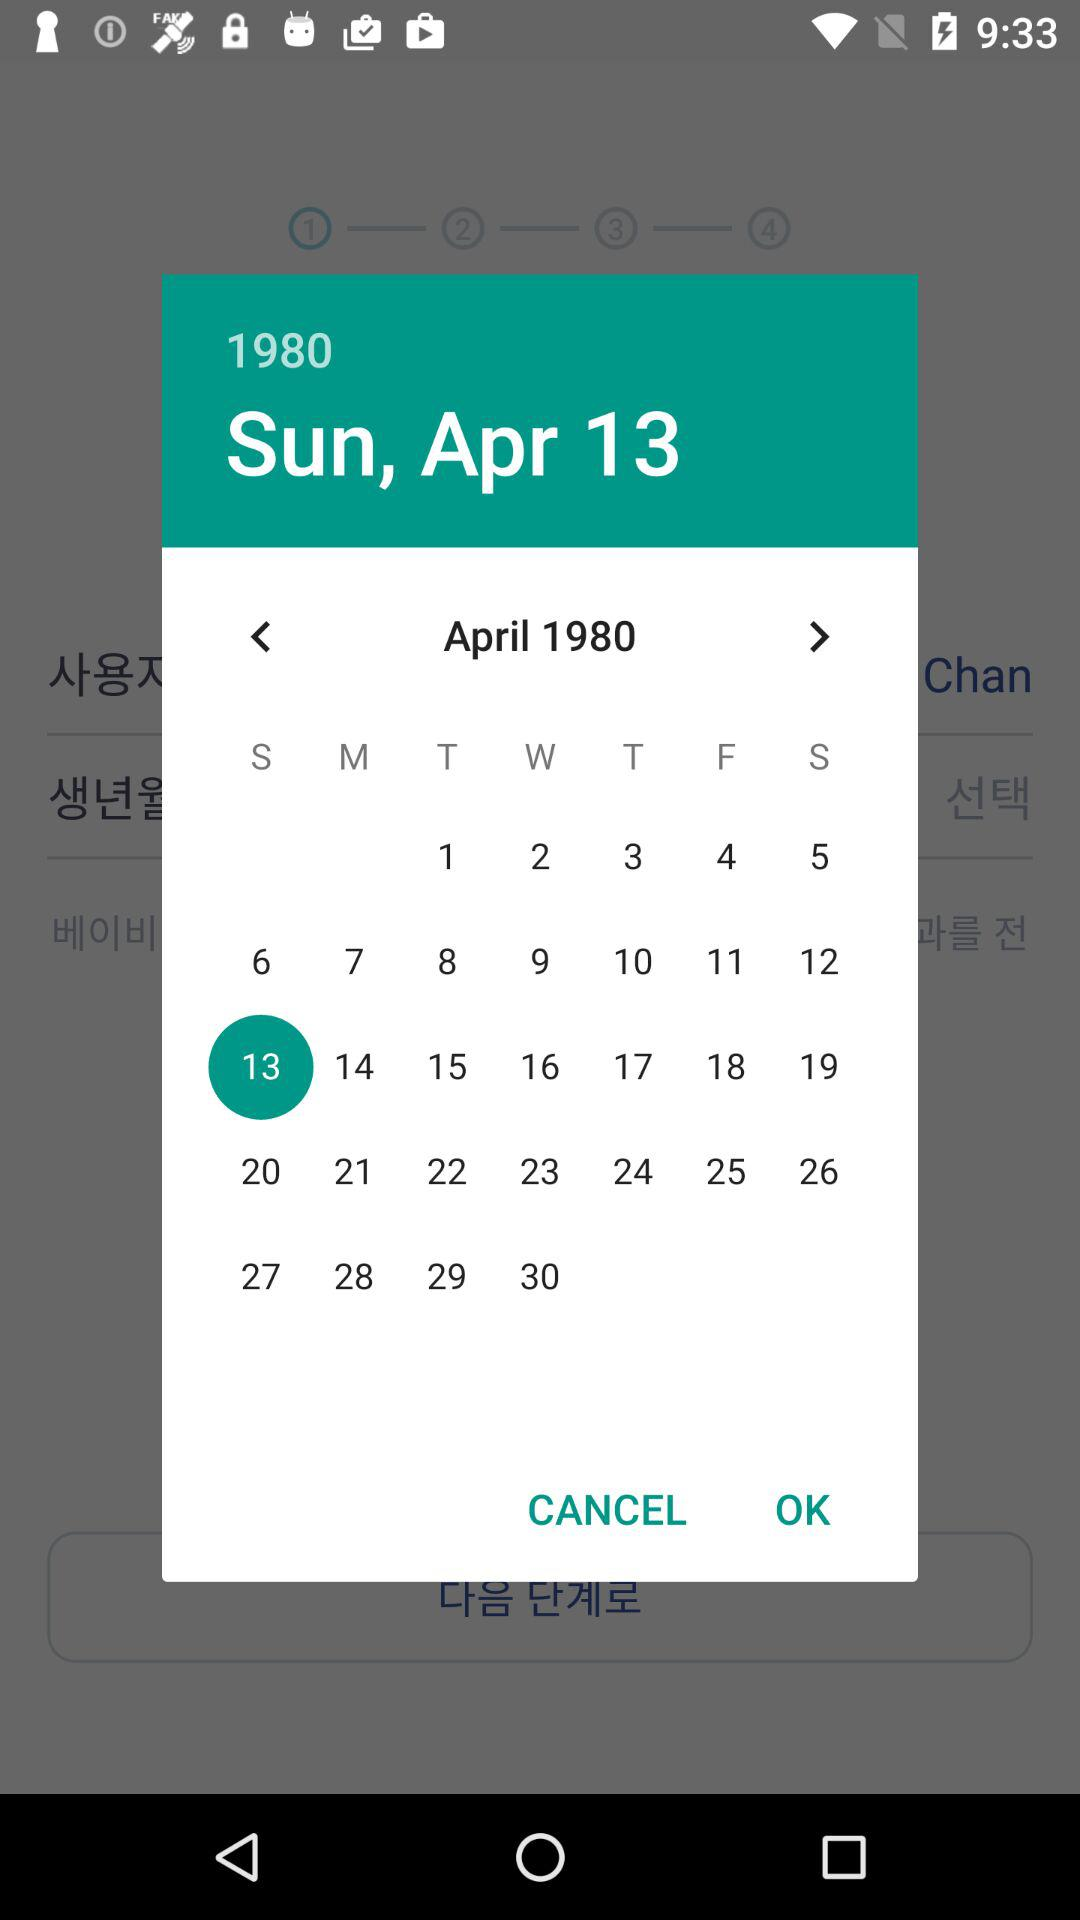What is the day on April 13, 1980? The day is Sunday. 